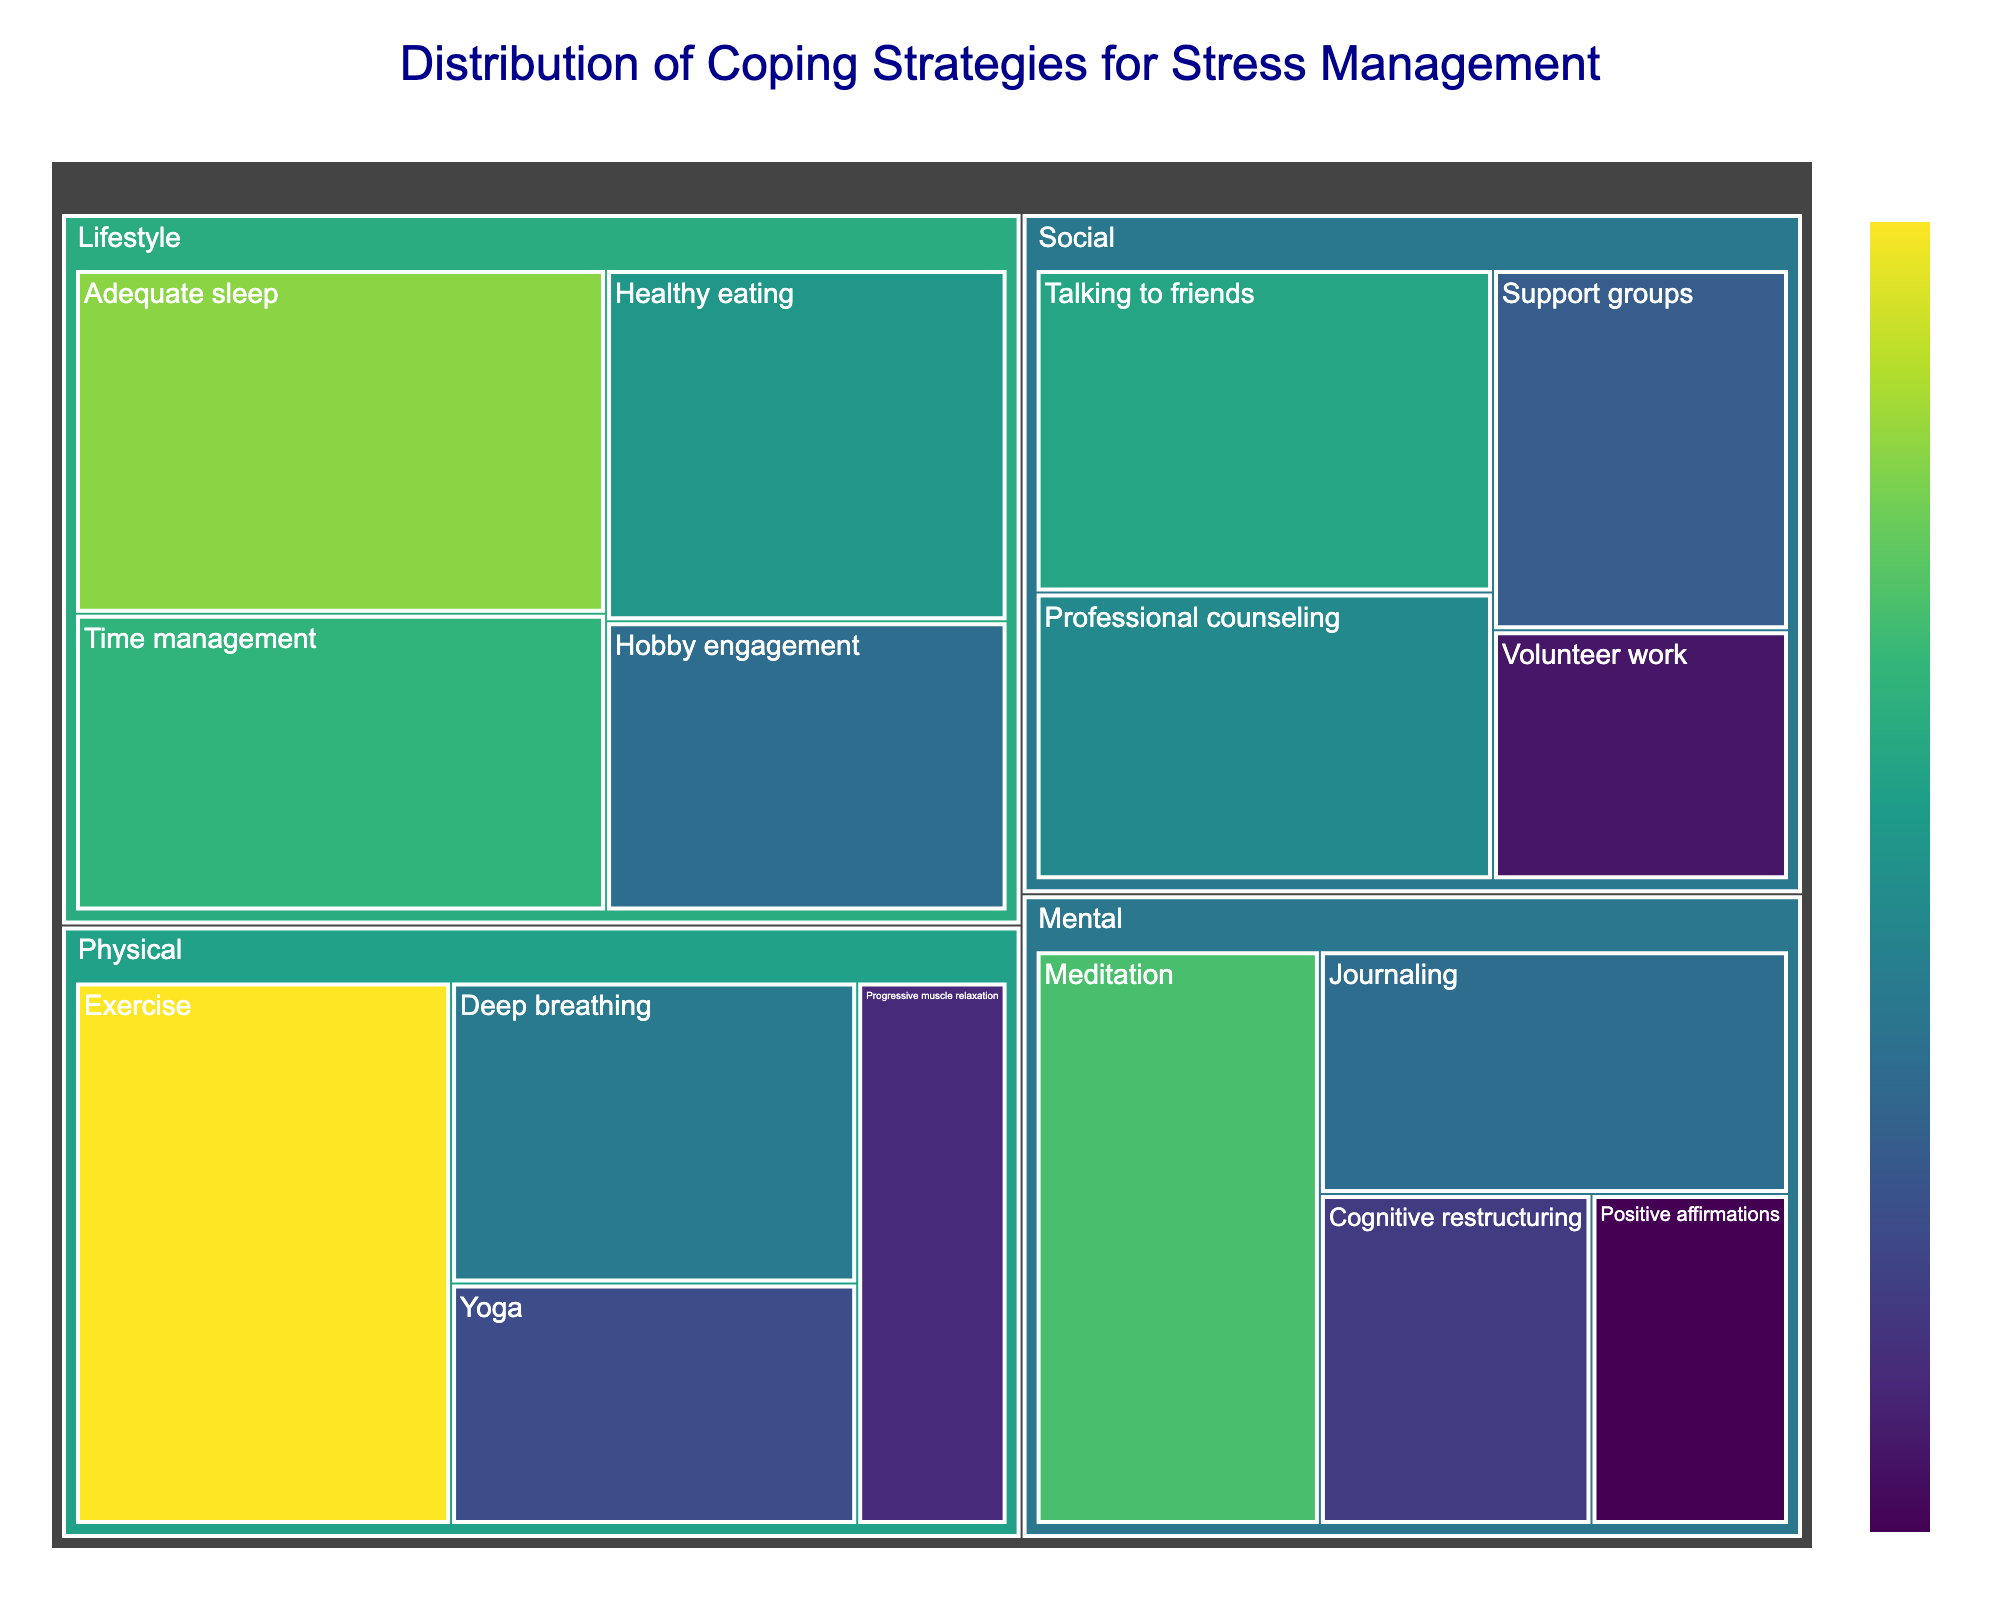What is the title of the treemap? The title is prominently displayed at the top of the plot and reads, 'Distribution of Coping Strategies for Stress Management'.
Answer: Distribution of Coping Strategies for Stress Management Which subcategory in the Physical category has the highest value? By looking at the areas of the subcategories within the Physical category, it is evident that 'Exercise' occupies the largest space, indicating it has the highest value.
Answer: Exercise How many subcategories are listed under the Mental category, and what is their average value? To determine the number of subcategories, simply count them under the Mental category (four: Meditation, Journaling, Positive affirmations, Cognitive restructuring). Sum their values (20 + 14 + 8 + 11 = 53) and divide by 4 to get the average (53 / 4 = 13.25).
Answer: 4 subcategories and the average value is 13.25 Compare the values of 'Professional counseling' and 'Support groups' in the Social category. Which one is higher and by how much? 'Professional counseling' is 16, while 'Support groups' is 13. The difference is calculated as 16 - 13 = 3.
Answer: Professional counseling is higher by 3 What is the combined value of all subcategories in the Lifestyle category? Add all the values of the subcategories in the Lifestyle category (Healthy eating, Adequate sleep, Time management, Hobby engagement): (17 + 22 + 19 + 14 = 72).
Answer: 72 Which category contains the subcategory with the highest value overall, and what is that value? By comparing subcategory values across all categories, 'Adequate sleep' in the Lifestyle category has the highest value of 22.
Answer: Lifestyle with a value of 22 What is the difference in value between 'Yoga' in the Physical category and 'Volunteer work' in the Social category? The value for 'Yoga' is 12, and for 'Volunteer work’ is 9. The difference is calculated as 12 - 9 = 3.
Answer: 3 How does the value of 'Meditation' compare to 'Exercise'? 'Meditation' has a value of 20, whereas 'Exercise' has a value of 25. This means 'Meditation' is 5 less than 'Exercise'.
Answer: ‘Meditation’ is 5 less than ‘Exercise’ 